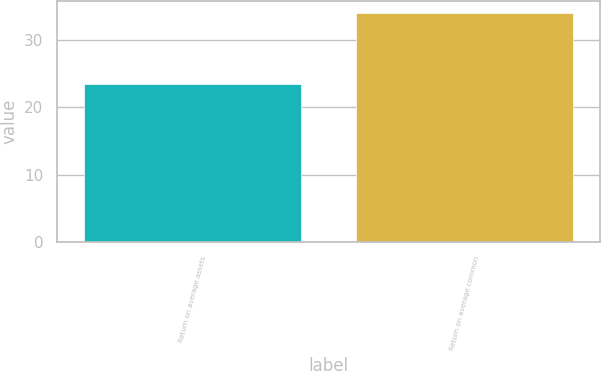Convert chart. <chart><loc_0><loc_0><loc_500><loc_500><bar_chart><fcel>Return on average assets<fcel>Return on average common<nl><fcel>23.4<fcel>34<nl></chart> 